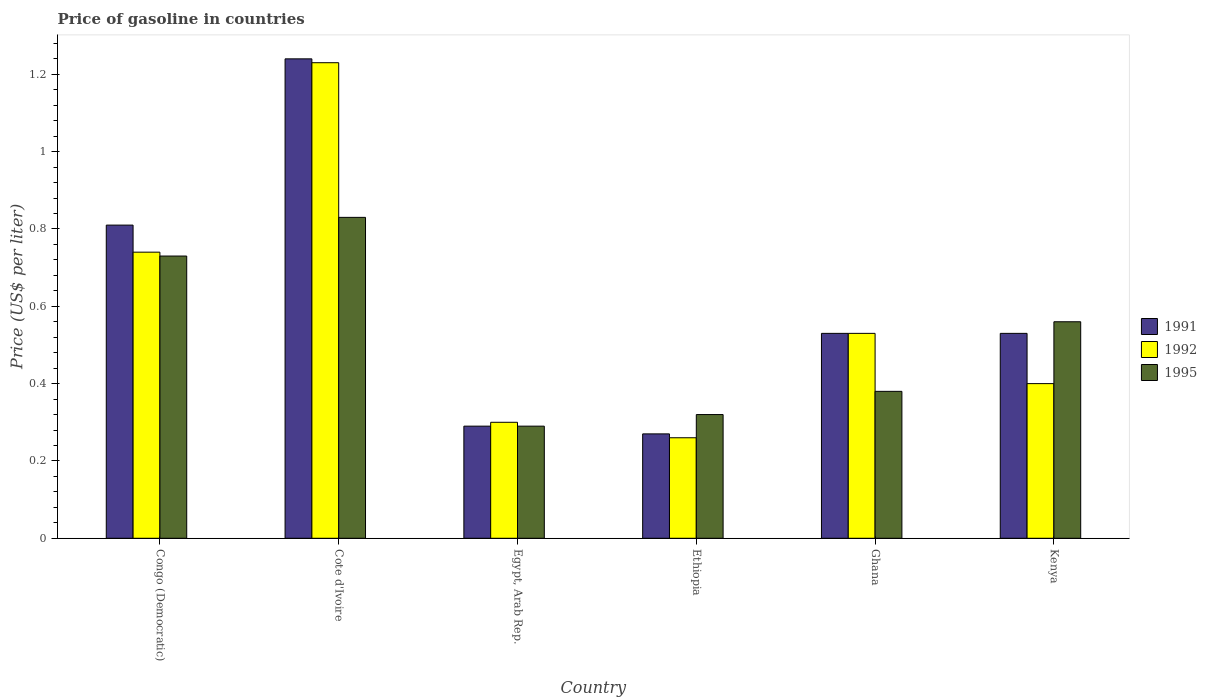Are the number of bars on each tick of the X-axis equal?
Provide a succinct answer. Yes. How many bars are there on the 3rd tick from the right?
Provide a short and direct response. 3. What is the label of the 4th group of bars from the left?
Your answer should be very brief. Ethiopia. What is the price of gasoline in 1992 in Egypt, Arab Rep.?
Provide a succinct answer. 0.3. Across all countries, what is the maximum price of gasoline in 1995?
Your answer should be compact. 0.83. Across all countries, what is the minimum price of gasoline in 1995?
Offer a very short reply. 0.29. In which country was the price of gasoline in 1995 maximum?
Your answer should be very brief. Cote d'Ivoire. In which country was the price of gasoline in 1992 minimum?
Keep it short and to the point. Ethiopia. What is the total price of gasoline in 1991 in the graph?
Give a very brief answer. 3.67. What is the difference between the price of gasoline in 1991 in Ethiopia and that in Kenya?
Your answer should be very brief. -0.26. What is the difference between the price of gasoline in 1992 in Ethiopia and the price of gasoline in 1995 in Ghana?
Your answer should be very brief. -0.12. What is the average price of gasoline in 1992 per country?
Keep it short and to the point. 0.58. In how many countries, is the price of gasoline in 1995 greater than 0.24000000000000002 US$?
Provide a short and direct response. 6. What is the ratio of the price of gasoline in 1992 in Cote d'Ivoire to that in Ghana?
Provide a succinct answer. 2.32. Is the price of gasoline in 1995 in Congo (Democratic) less than that in Ghana?
Ensure brevity in your answer.  No. What is the difference between the highest and the second highest price of gasoline in 1995?
Keep it short and to the point. 0.1. Is the sum of the price of gasoline in 1995 in Congo (Democratic) and Egypt, Arab Rep. greater than the maximum price of gasoline in 1992 across all countries?
Offer a very short reply. No. What does the 1st bar from the right in Cote d'Ivoire represents?
Provide a short and direct response. 1995. Is it the case that in every country, the sum of the price of gasoline in 1992 and price of gasoline in 1991 is greater than the price of gasoline in 1995?
Provide a succinct answer. Yes. How many countries are there in the graph?
Your answer should be compact. 6. What is the difference between two consecutive major ticks on the Y-axis?
Offer a very short reply. 0.2. How many legend labels are there?
Provide a succinct answer. 3. What is the title of the graph?
Provide a short and direct response. Price of gasoline in countries. Does "1996" appear as one of the legend labels in the graph?
Ensure brevity in your answer.  No. What is the label or title of the X-axis?
Keep it short and to the point. Country. What is the label or title of the Y-axis?
Make the answer very short. Price (US$ per liter). What is the Price (US$ per liter) in 1991 in Congo (Democratic)?
Provide a succinct answer. 0.81. What is the Price (US$ per liter) in 1992 in Congo (Democratic)?
Provide a succinct answer. 0.74. What is the Price (US$ per liter) in 1995 in Congo (Democratic)?
Your answer should be very brief. 0.73. What is the Price (US$ per liter) in 1991 in Cote d'Ivoire?
Ensure brevity in your answer.  1.24. What is the Price (US$ per liter) in 1992 in Cote d'Ivoire?
Provide a succinct answer. 1.23. What is the Price (US$ per liter) in 1995 in Cote d'Ivoire?
Offer a very short reply. 0.83. What is the Price (US$ per liter) of 1991 in Egypt, Arab Rep.?
Your answer should be compact. 0.29. What is the Price (US$ per liter) in 1992 in Egypt, Arab Rep.?
Keep it short and to the point. 0.3. What is the Price (US$ per liter) of 1995 in Egypt, Arab Rep.?
Ensure brevity in your answer.  0.29. What is the Price (US$ per liter) of 1991 in Ethiopia?
Offer a very short reply. 0.27. What is the Price (US$ per liter) in 1992 in Ethiopia?
Your answer should be compact. 0.26. What is the Price (US$ per liter) of 1995 in Ethiopia?
Make the answer very short. 0.32. What is the Price (US$ per liter) of 1991 in Ghana?
Offer a terse response. 0.53. What is the Price (US$ per liter) of 1992 in Ghana?
Keep it short and to the point. 0.53. What is the Price (US$ per liter) of 1995 in Ghana?
Provide a short and direct response. 0.38. What is the Price (US$ per liter) of 1991 in Kenya?
Keep it short and to the point. 0.53. What is the Price (US$ per liter) of 1992 in Kenya?
Your answer should be very brief. 0.4. What is the Price (US$ per liter) of 1995 in Kenya?
Keep it short and to the point. 0.56. Across all countries, what is the maximum Price (US$ per liter) of 1991?
Provide a succinct answer. 1.24. Across all countries, what is the maximum Price (US$ per liter) of 1992?
Your response must be concise. 1.23. Across all countries, what is the maximum Price (US$ per liter) of 1995?
Your answer should be very brief. 0.83. Across all countries, what is the minimum Price (US$ per liter) in 1991?
Offer a terse response. 0.27. Across all countries, what is the minimum Price (US$ per liter) of 1992?
Offer a terse response. 0.26. Across all countries, what is the minimum Price (US$ per liter) in 1995?
Your answer should be very brief. 0.29. What is the total Price (US$ per liter) in 1991 in the graph?
Give a very brief answer. 3.67. What is the total Price (US$ per liter) in 1992 in the graph?
Your answer should be compact. 3.46. What is the total Price (US$ per liter) of 1995 in the graph?
Your answer should be compact. 3.11. What is the difference between the Price (US$ per liter) in 1991 in Congo (Democratic) and that in Cote d'Ivoire?
Make the answer very short. -0.43. What is the difference between the Price (US$ per liter) of 1992 in Congo (Democratic) and that in Cote d'Ivoire?
Provide a succinct answer. -0.49. What is the difference between the Price (US$ per liter) of 1991 in Congo (Democratic) and that in Egypt, Arab Rep.?
Make the answer very short. 0.52. What is the difference between the Price (US$ per liter) in 1992 in Congo (Democratic) and that in Egypt, Arab Rep.?
Your answer should be compact. 0.44. What is the difference between the Price (US$ per liter) in 1995 in Congo (Democratic) and that in Egypt, Arab Rep.?
Offer a terse response. 0.44. What is the difference between the Price (US$ per liter) of 1991 in Congo (Democratic) and that in Ethiopia?
Your answer should be compact. 0.54. What is the difference between the Price (US$ per liter) of 1992 in Congo (Democratic) and that in Ethiopia?
Ensure brevity in your answer.  0.48. What is the difference between the Price (US$ per liter) in 1995 in Congo (Democratic) and that in Ethiopia?
Your answer should be compact. 0.41. What is the difference between the Price (US$ per liter) in 1991 in Congo (Democratic) and that in Ghana?
Give a very brief answer. 0.28. What is the difference between the Price (US$ per liter) in 1992 in Congo (Democratic) and that in Ghana?
Keep it short and to the point. 0.21. What is the difference between the Price (US$ per liter) in 1995 in Congo (Democratic) and that in Ghana?
Your response must be concise. 0.35. What is the difference between the Price (US$ per liter) of 1991 in Congo (Democratic) and that in Kenya?
Your answer should be compact. 0.28. What is the difference between the Price (US$ per liter) in 1992 in Congo (Democratic) and that in Kenya?
Your answer should be very brief. 0.34. What is the difference between the Price (US$ per liter) in 1995 in Congo (Democratic) and that in Kenya?
Ensure brevity in your answer.  0.17. What is the difference between the Price (US$ per liter) of 1991 in Cote d'Ivoire and that in Egypt, Arab Rep.?
Make the answer very short. 0.95. What is the difference between the Price (US$ per liter) in 1992 in Cote d'Ivoire and that in Egypt, Arab Rep.?
Your answer should be compact. 0.93. What is the difference between the Price (US$ per liter) of 1995 in Cote d'Ivoire and that in Egypt, Arab Rep.?
Give a very brief answer. 0.54. What is the difference between the Price (US$ per liter) of 1991 in Cote d'Ivoire and that in Ethiopia?
Provide a short and direct response. 0.97. What is the difference between the Price (US$ per liter) in 1995 in Cote d'Ivoire and that in Ethiopia?
Provide a short and direct response. 0.51. What is the difference between the Price (US$ per liter) in 1991 in Cote d'Ivoire and that in Ghana?
Give a very brief answer. 0.71. What is the difference between the Price (US$ per liter) of 1992 in Cote d'Ivoire and that in Ghana?
Make the answer very short. 0.7. What is the difference between the Price (US$ per liter) of 1995 in Cote d'Ivoire and that in Ghana?
Your answer should be very brief. 0.45. What is the difference between the Price (US$ per liter) in 1991 in Cote d'Ivoire and that in Kenya?
Offer a very short reply. 0.71. What is the difference between the Price (US$ per liter) in 1992 in Cote d'Ivoire and that in Kenya?
Your answer should be very brief. 0.83. What is the difference between the Price (US$ per liter) in 1995 in Cote d'Ivoire and that in Kenya?
Offer a very short reply. 0.27. What is the difference between the Price (US$ per liter) of 1992 in Egypt, Arab Rep. and that in Ethiopia?
Provide a succinct answer. 0.04. What is the difference between the Price (US$ per liter) in 1995 in Egypt, Arab Rep. and that in Ethiopia?
Offer a terse response. -0.03. What is the difference between the Price (US$ per liter) of 1991 in Egypt, Arab Rep. and that in Ghana?
Give a very brief answer. -0.24. What is the difference between the Price (US$ per liter) in 1992 in Egypt, Arab Rep. and that in Ghana?
Your answer should be compact. -0.23. What is the difference between the Price (US$ per liter) in 1995 in Egypt, Arab Rep. and that in Ghana?
Offer a very short reply. -0.09. What is the difference between the Price (US$ per liter) of 1991 in Egypt, Arab Rep. and that in Kenya?
Your answer should be compact. -0.24. What is the difference between the Price (US$ per liter) of 1992 in Egypt, Arab Rep. and that in Kenya?
Offer a very short reply. -0.1. What is the difference between the Price (US$ per liter) in 1995 in Egypt, Arab Rep. and that in Kenya?
Ensure brevity in your answer.  -0.27. What is the difference between the Price (US$ per liter) of 1991 in Ethiopia and that in Ghana?
Provide a succinct answer. -0.26. What is the difference between the Price (US$ per liter) of 1992 in Ethiopia and that in Ghana?
Make the answer very short. -0.27. What is the difference between the Price (US$ per liter) in 1995 in Ethiopia and that in Ghana?
Ensure brevity in your answer.  -0.06. What is the difference between the Price (US$ per liter) of 1991 in Ethiopia and that in Kenya?
Your answer should be very brief. -0.26. What is the difference between the Price (US$ per liter) in 1992 in Ethiopia and that in Kenya?
Make the answer very short. -0.14. What is the difference between the Price (US$ per liter) of 1995 in Ethiopia and that in Kenya?
Give a very brief answer. -0.24. What is the difference between the Price (US$ per liter) in 1991 in Ghana and that in Kenya?
Give a very brief answer. 0. What is the difference between the Price (US$ per liter) of 1992 in Ghana and that in Kenya?
Offer a terse response. 0.13. What is the difference between the Price (US$ per liter) in 1995 in Ghana and that in Kenya?
Offer a very short reply. -0.18. What is the difference between the Price (US$ per liter) of 1991 in Congo (Democratic) and the Price (US$ per liter) of 1992 in Cote d'Ivoire?
Ensure brevity in your answer.  -0.42. What is the difference between the Price (US$ per liter) in 1991 in Congo (Democratic) and the Price (US$ per liter) in 1995 in Cote d'Ivoire?
Your answer should be very brief. -0.02. What is the difference between the Price (US$ per liter) in 1992 in Congo (Democratic) and the Price (US$ per liter) in 1995 in Cote d'Ivoire?
Provide a short and direct response. -0.09. What is the difference between the Price (US$ per liter) of 1991 in Congo (Democratic) and the Price (US$ per liter) of 1992 in Egypt, Arab Rep.?
Provide a short and direct response. 0.51. What is the difference between the Price (US$ per liter) in 1991 in Congo (Democratic) and the Price (US$ per liter) in 1995 in Egypt, Arab Rep.?
Ensure brevity in your answer.  0.52. What is the difference between the Price (US$ per liter) of 1992 in Congo (Democratic) and the Price (US$ per liter) of 1995 in Egypt, Arab Rep.?
Offer a very short reply. 0.45. What is the difference between the Price (US$ per liter) of 1991 in Congo (Democratic) and the Price (US$ per liter) of 1992 in Ethiopia?
Provide a succinct answer. 0.55. What is the difference between the Price (US$ per liter) in 1991 in Congo (Democratic) and the Price (US$ per liter) in 1995 in Ethiopia?
Keep it short and to the point. 0.49. What is the difference between the Price (US$ per liter) of 1992 in Congo (Democratic) and the Price (US$ per liter) of 1995 in Ethiopia?
Provide a succinct answer. 0.42. What is the difference between the Price (US$ per liter) in 1991 in Congo (Democratic) and the Price (US$ per liter) in 1992 in Ghana?
Offer a terse response. 0.28. What is the difference between the Price (US$ per liter) in 1991 in Congo (Democratic) and the Price (US$ per liter) in 1995 in Ghana?
Keep it short and to the point. 0.43. What is the difference between the Price (US$ per liter) of 1992 in Congo (Democratic) and the Price (US$ per liter) of 1995 in Ghana?
Offer a terse response. 0.36. What is the difference between the Price (US$ per liter) of 1991 in Congo (Democratic) and the Price (US$ per liter) of 1992 in Kenya?
Ensure brevity in your answer.  0.41. What is the difference between the Price (US$ per liter) in 1992 in Congo (Democratic) and the Price (US$ per liter) in 1995 in Kenya?
Keep it short and to the point. 0.18. What is the difference between the Price (US$ per liter) of 1991 in Cote d'Ivoire and the Price (US$ per liter) of 1995 in Egypt, Arab Rep.?
Give a very brief answer. 0.95. What is the difference between the Price (US$ per liter) in 1991 in Cote d'Ivoire and the Price (US$ per liter) in 1992 in Ethiopia?
Give a very brief answer. 0.98. What is the difference between the Price (US$ per liter) of 1992 in Cote d'Ivoire and the Price (US$ per liter) of 1995 in Ethiopia?
Provide a succinct answer. 0.91. What is the difference between the Price (US$ per liter) in 1991 in Cote d'Ivoire and the Price (US$ per liter) in 1992 in Ghana?
Make the answer very short. 0.71. What is the difference between the Price (US$ per liter) in 1991 in Cote d'Ivoire and the Price (US$ per liter) in 1995 in Ghana?
Provide a short and direct response. 0.86. What is the difference between the Price (US$ per liter) in 1992 in Cote d'Ivoire and the Price (US$ per liter) in 1995 in Ghana?
Ensure brevity in your answer.  0.85. What is the difference between the Price (US$ per liter) in 1991 in Cote d'Ivoire and the Price (US$ per liter) in 1992 in Kenya?
Provide a succinct answer. 0.84. What is the difference between the Price (US$ per liter) of 1991 in Cote d'Ivoire and the Price (US$ per liter) of 1995 in Kenya?
Ensure brevity in your answer.  0.68. What is the difference between the Price (US$ per liter) of 1992 in Cote d'Ivoire and the Price (US$ per liter) of 1995 in Kenya?
Offer a very short reply. 0.67. What is the difference between the Price (US$ per liter) in 1991 in Egypt, Arab Rep. and the Price (US$ per liter) in 1992 in Ethiopia?
Keep it short and to the point. 0.03. What is the difference between the Price (US$ per liter) of 1991 in Egypt, Arab Rep. and the Price (US$ per liter) of 1995 in Ethiopia?
Offer a terse response. -0.03. What is the difference between the Price (US$ per liter) of 1992 in Egypt, Arab Rep. and the Price (US$ per liter) of 1995 in Ethiopia?
Your answer should be compact. -0.02. What is the difference between the Price (US$ per liter) in 1991 in Egypt, Arab Rep. and the Price (US$ per liter) in 1992 in Ghana?
Your answer should be compact. -0.24. What is the difference between the Price (US$ per liter) in 1991 in Egypt, Arab Rep. and the Price (US$ per liter) in 1995 in Ghana?
Offer a very short reply. -0.09. What is the difference between the Price (US$ per liter) in 1992 in Egypt, Arab Rep. and the Price (US$ per liter) in 1995 in Ghana?
Provide a short and direct response. -0.08. What is the difference between the Price (US$ per liter) in 1991 in Egypt, Arab Rep. and the Price (US$ per liter) in 1992 in Kenya?
Your response must be concise. -0.11. What is the difference between the Price (US$ per liter) of 1991 in Egypt, Arab Rep. and the Price (US$ per liter) of 1995 in Kenya?
Provide a short and direct response. -0.27. What is the difference between the Price (US$ per liter) of 1992 in Egypt, Arab Rep. and the Price (US$ per liter) of 1995 in Kenya?
Provide a succinct answer. -0.26. What is the difference between the Price (US$ per liter) of 1991 in Ethiopia and the Price (US$ per liter) of 1992 in Ghana?
Provide a short and direct response. -0.26. What is the difference between the Price (US$ per liter) of 1991 in Ethiopia and the Price (US$ per liter) of 1995 in Ghana?
Provide a succinct answer. -0.11. What is the difference between the Price (US$ per liter) in 1992 in Ethiopia and the Price (US$ per liter) in 1995 in Ghana?
Your response must be concise. -0.12. What is the difference between the Price (US$ per liter) in 1991 in Ethiopia and the Price (US$ per liter) in 1992 in Kenya?
Your answer should be very brief. -0.13. What is the difference between the Price (US$ per liter) in 1991 in Ethiopia and the Price (US$ per liter) in 1995 in Kenya?
Your response must be concise. -0.29. What is the difference between the Price (US$ per liter) in 1991 in Ghana and the Price (US$ per liter) in 1992 in Kenya?
Your response must be concise. 0.13. What is the difference between the Price (US$ per liter) in 1991 in Ghana and the Price (US$ per liter) in 1995 in Kenya?
Offer a terse response. -0.03. What is the difference between the Price (US$ per liter) in 1992 in Ghana and the Price (US$ per liter) in 1995 in Kenya?
Keep it short and to the point. -0.03. What is the average Price (US$ per liter) in 1991 per country?
Ensure brevity in your answer.  0.61. What is the average Price (US$ per liter) of 1992 per country?
Your response must be concise. 0.58. What is the average Price (US$ per liter) in 1995 per country?
Keep it short and to the point. 0.52. What is the difference between the Price (US$ per liter) in 1991 and Price (US$ per liter) in 1992 in Congo (Democratic)?
Keep it short and to the point. 0.07. What is the difference between the Price (US$ per liter) of 1991 and Price (US$ per liter) of 1995 in Congo (Democratic)?
Offer a very short reply. 0.08. What is the difference between the Price (US$ per liter) in 1992 and Price (US$ per liter) in 1995 in Congo (Democratic)?
Make the answer very short. 0.01. What is the difference between the Price (US$ per liter) in 1991 and Price (US$ per liter) in 1992 in Cote d'Ivoire?
Make the answer very short. 0.01. What is the difference between the Price (US$ per liter) in 1991 and Price (US$ per liter) in 1995 in Cote d'Ivoire?
Your response must be concise. 0.41. What is the difference between the Price (US$ per liter) of 1991 and Price (US$ per liter) of 1992 in Egypt, Arab Rep.?
Offer a terse response. -0.01. What is the difference between the Price (US$ per liter) of 1992 and Price (US$ per liter) of 1995 in Egypt, Arab Rep.?
Keep it short and to the point. 0.01. What is the difference between the Price (US$ per liter) in 1991 and Price (US$ per liter) in 1992 in Ethiopia?
Provide a succinct answer. 0.01. What is the difference between the Price (US$ per liter) of 1992 and Price (US$ per liter) of 1995 in Ethiopia?
Make the answer very short. -0.06. What is the difference between the Price (US$ per liter) of 1991 and Price (US$ per liter) of 1992 in Ghana?
Give a very brief answer. 0. What is the difference between the Price (US$ per liter) in 1992 and Price (US$ per liter) in 1995 in Ghana?
Make the answer very short. 0.15. What is the difference between the Price (US$ per liter) in 1991 and Price (US$ per liter) in 1992 in Kenya?
Make the answer very short. 0.13. What is the difference between the Price (US$ per liter) in 1991 and Price (US$ per liter) in 1995 in Kenya?
Provide a succinct answer. -0.03. What is the difference between the Price (US$ per liter) in 1992 and Price (US$ per liter) in 1995 in Kenya?
Your answer should be compact. -0.16. What is the ratio of the Price (US$ per liter) in 1991 in Congo (Democratic) to that in Cote d'Ivoire?
Your answer should be compact. 0.65. What is the ratio of the Price (US$ per liter) in 1992 in Congo (Democratic) to that in Cote d'Ivoire?
Make the answer very short. 0.6. What is the ratio of the Price (US$ per liter) in 1995 in Congo (Democratic) to that in Cote d'Ivoire?
Provide a succinct answer. 0.88. What is the ratio of the Price (US$ per liter) of 1991 in Congo (Democratic) to that in Egypt, Arab Rep.?
Offer a very short reply. 2.79. What is the ratio of the Price (US$ per liter) in 1992 in Congo (Democratic) to that in Egypt, Arab Rep.?
Your answer should be compact. 2.47. What is the ratio of the Price (US$ per liter) of 1995 in Congo (Democratic) to that in Egypt, Arab Rep.?
Make the answer very short. 2.52. What is the ratio of the Price (US$ per liter) in 1992 in Congo (Democratic) to that in Ethiopia?
Keep it short and to the point. 2.85. What is the ratio of the Price (US$ per liter) in 1995 in Congo (Democratic) to that in Ethiopia?
Ensure brevity in your answer.  2.28. What is the ratio of the Price (US$ per liter) of 1991 in Congo (Democratic) to that in Ghana?
Make the answer very short. 1.53. What is the ratio of the Price (US$ per liter) in 1992 in Congo (Democratic) to that in Ghana?
Give a very brief answer. 1.4. What is the ratio of the Price (US$ per liter) of 1995 in Congo (Democratic) to that in Ghana?
Offer a terse response. 1.92. What is the ratio of the Price (US$ per liter) of 1991 in Congo (Democratic) to that in Kenya?
Your response must be concise. 1.53. What is the ratio of the Price (US$ per liter) in 1992 in Congo (Democratic) to that in Kenya?
Provide a short and direct response. 1.85. What is the ratio of the Price (US$ per liter) of 1995 in Congo (Democratic) to that in Kenya?
Your answer should be compact. 1.3. What is the ratio of the Price (US$ per liter) in 1991 in Cote d'Ivoire to that in Egypt, Arab Rep.?
Give a very brief answer. 4.28. What is the ratio of the Price (US$ per liter) of 1995 in Cote d'Ivoire to that in Egypt, Arab Rep.?
Give a very brief answer. 2.86. What is the ratio of the Price (US$ per liter) of 1991 in Cote d'Ivoire to that in Ethiopia?
Keep it short and to the point. 4.59. What is the ratio of the Price (US$ per liter) in 1992 in Cote d'Ivoire to that in Ethiopia?
Your answer should be very brief. 4.73. What is the ratio of the Price (US$ per liter) in 1995 in Cote d'Ivoire to that in Ethiopia?
Give a very brief answer. 2.59. What is the ratio of the Price (US$ per liter) in 1991 in Cote d'Ivoire to that in Ghana?
Provide a short and direct response. 2.34. What is the ratio of the Price (US$ per liter) of 1992 in Cote d'Ivoire to that in Ghana?
Offer a very short reply. 2.32. What is the ratio of the Price (US$ per liter) in 1995 in Cote d'Ivoire to that in Ghana?
Your answer should be compact. 2.18. What is the ratio of the Price (US$ per liter) in 1991 in Cote d'Ivoire to that in Kenya?
Your response must be concise. 2.34. What is the ratio of the Price (US$ per liter) of 1992 in Cote d'Ivoire to that in Kenya?
Your answer should be very brief. 3.08. What is the ratio of the Price (US$ per liter) of 1995 in Cote d'Ivoire to that in Kenya?
Make the answer very short. 1.48. What is the ratio of the Price (US$ per liter) of 1991 in Egypt, Arab Rep. to that in Ethiopia?
Offer a very short reply. 1.07. What is the ratio of the Price (US$ per liter) of 1992 in Egypt, Arab Rep. to that in Ethiopia?
Keep it short and to the point. 1.15. What is the ratio of the Price (US$ per liter) of 1995 in Egypt, Arab Rep. to that in Ethiopia?
Give a very brief answer. 0.91. What is the ratio of the Price (US$ per liter) in 1991 in Egypt, Arab Rep. to that in Ghana?
Provide a succinct answer. 0.55. What is the ratio of the Price (US$ per liter) in 1992 in Egypt, Arab Rep. to that in Ghana?
Your answer should be very brief. 0.57. What is the ratio of the Price (US$ per liter) in 1995 in Egypt, Arab Rep. to that in Ghana?
Keep it short and to the point. 0.76. What is the ratio of the Price (US$ per liter) of 1991 in Egypt, Arab Rep. to that in Kenya?
Your answer should be compact. 0.55. What is the ratio of the Price (US$ per liter) of 1992 in Egypt, Arab Rep. to that in Kenya?
Keep it short and to the point. 0.75. What is the ratio of the Price (US$ per liter) in 1995 in Egypt, Arab Rep. to that in Kenya?
Offer a very short reply. 0.52. What is the ratio of the Price (US$ per liter) of 1991 in Ethiopia to that in Ghana?
Offer a very short reply. 0.51. What is the ratio of the Price (US$ per liter) in 1992 in Ethiopia to that in Ghana?
Offer a terse response. 0.49. What is the ratio of the Price (US$ per liter) of 1995 in Ethiopia to that in Ghana?
Offer a terse response. 0.84. What is the ratio of the Price (US$ per liter) of 1991 in Ethiopia to that in Kenya?
Provide a succinct answer. 0.51. What is the ratio of the Price (US$ per liter) of 1992 in Ethiopia to that in Kenya?
Make the answer very short. 0.65. What is the ratio of the Price (US$ per liter) in 1995 in Ethiopia to that in Kenya?
Your answer should be compact. 0.57. What is the ratio of the Price (US$ per liter) of 1991 in Ghana to that in Kenya?
Your response must be concise. 1. What is the ratio of the Price (US$ per liter) of 1992 in Ghana to that in Kenya?
Keep it short and to the point. 1.32. What is the ratio of the Price (US$ per liter) in 1995 in Ghana to that in Kenya?
Provide a succinct answer. 0.68. What is the difference between the highest and the second highest Price (US$ per liter) of 1991?
Provide a short and direct response. 0.43. What is the difference between the highest and the second highest Price (US$ per liter) of 1992?
Offer a very short reply. 0.49. What is the difference between the highest and the lowest Price (US$ per liter) in 1992?
Provide a succinct answer. 0.97. What is the difference between the highest and the lowest Price (US$ per liter) of 1995?
Your response must be concise. 0.54. 